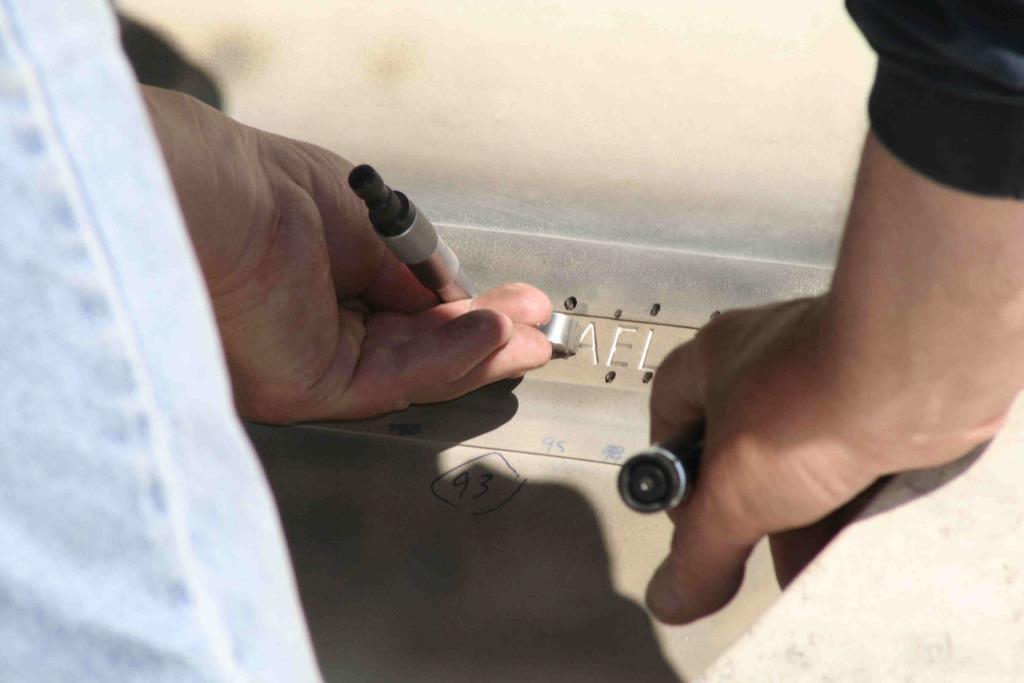How would you summarize this image in a sentence or two? In this picture there are two hands in the center of the image, by holding tools and there is a plywood in the center of the image. 